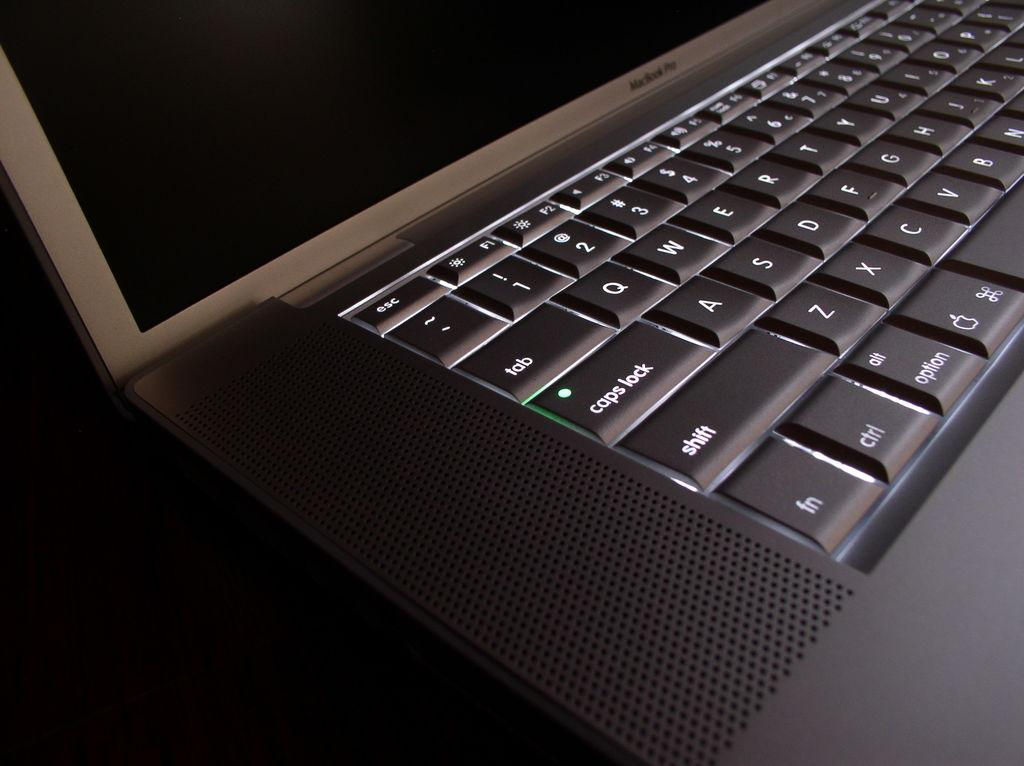<image>
Share a concise interpretation of the image provided. a close up of a MacBook Pro lap top keyboard 